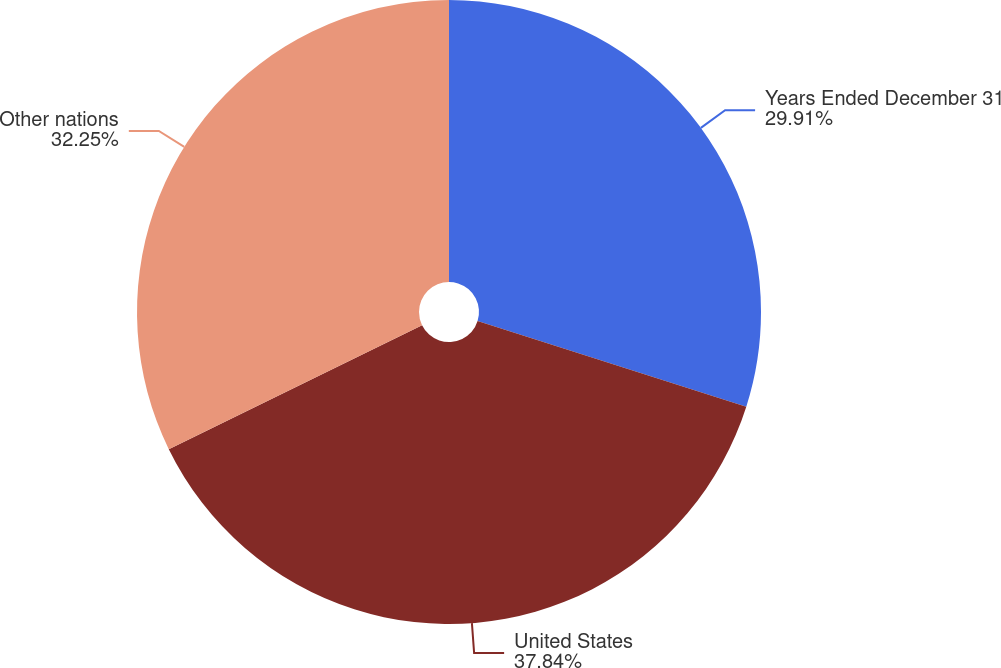Convert chart to OTSL. <chart><loc_0><loc_0><loc_500><loc_500><pie_chart><fcel>Years Ended December 31<fcel>United States<fcel>Other nations<nl><fcel>29.91%<fcel>37.85%<fcel>32.25%<nl></chart> 